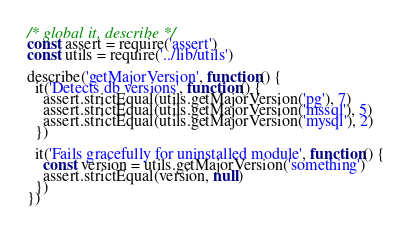<code> <loc_0><loc_0><loc_500><loc_500><_JavaScript_>/* global it, describe */
const assert = require('assert')
const utils = require('../lib/utils')

describe('getMajorVersion', function() {
  it('Detects db versions', function() {
    assert.strictEqual(utils.getMajorVersion('pg'), 7)
    assert.strictEqual(utils.getMajorVersion('mssql'), 5)
    assert.strictEqual(utils.getMajorVersion('mysql'), 2)
  })

  it('Fails gracefully for uninstalled module', function() {
    const version = utils.getMajorVersion('something')
    assert.strictEqual(version, null)
  })
})
</code> 